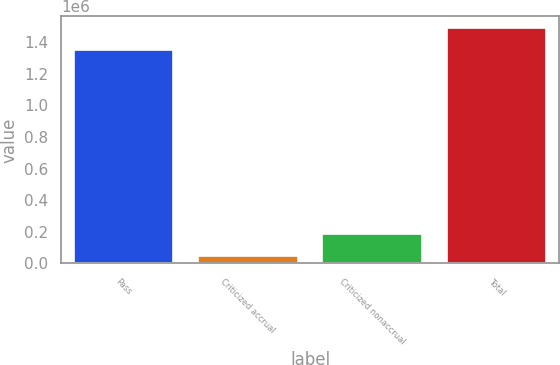Convert chart to OTSL. <chart><loc_0><loc_0><loc_500><loc_500><bar_chart><fcel>Pass<fcel>Criticized accrual<fcel>Criticized nonaccrual<fcel>Total<nl><fcel>1.34778e+06<fcel>45845<fcel>187774<fcel>1.48971e+06<nl></chart> 